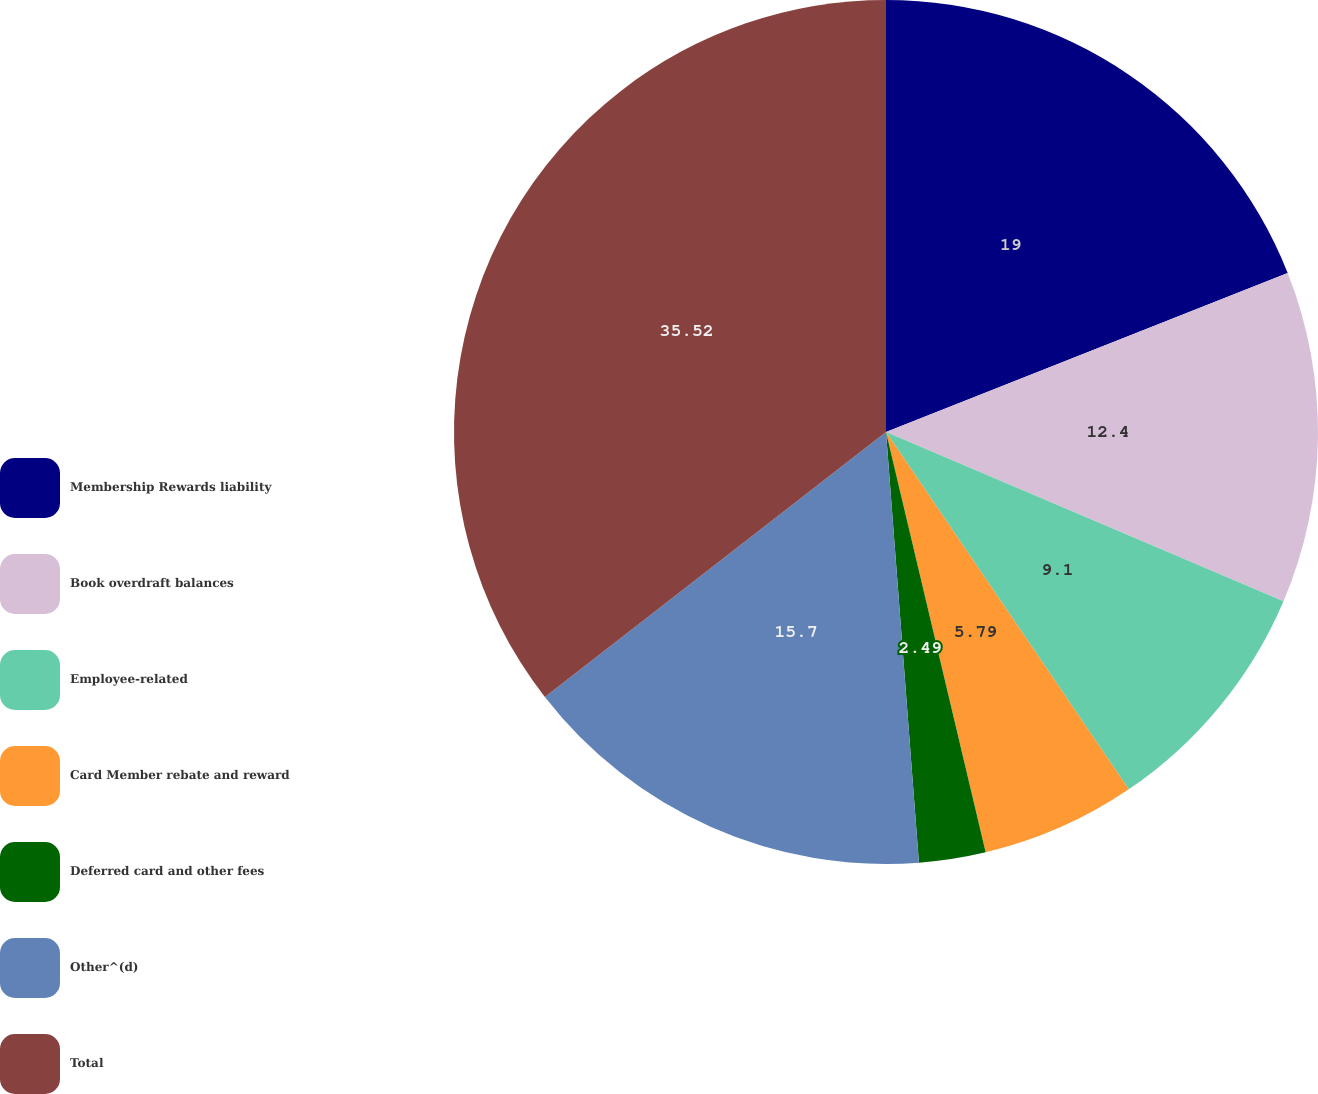Convert chart. <chart><loc_0><loc_0><loc_500><loc_500><pie_chart><fcel>Membership Rewards liability<fcel>Book overdraft balances<fcel>Employee-related<fcel>Card Member rebate and reward<fcel>Deferred card and other fees<fcel>Other^(d)<fcel>Total<nl><fcel>19.0%<fcel>12.4%<fcel>9.1%<fcel>5.79%<fcel>2.49%<fcel>15.7%<fcel>35.51%<nl></chart> 